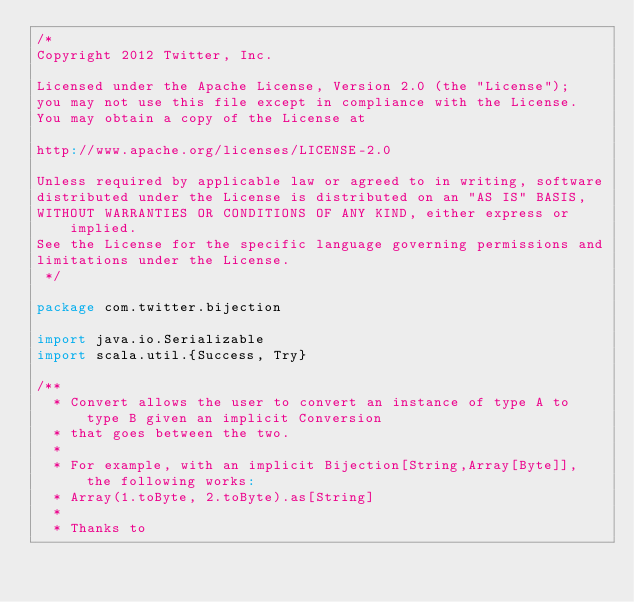<code> <loc_0><loc_0><loc_500><loc_500><_Scala_>/*
Copyright 2012 Twitter, Inc.

Licensed under the Apache License, Version 2.0 (the "License");
you may not use this file except in compliance with the License.
You may obtain a copy of the License at

http://www.apache.org/licenses/LICENSE-2.0

Unless required by applicable law or agreed to in writing, software
distributed under the License is distributed on an "AS IS" BASIS,
WITHOUT WARRANTIES OR CONDITIONS OF ANY KIND, either express or implied.
See the License for the specific language governing permissions and
limitations under the License.
 */

package com.twitter.bijection

import java.io.Serializable
import scala.util.{Success, Try}

/**
  * Convert allows the user to convert an instance of type A to type B given an implicit Conversion
  * that goes between the two.
  *
  * For example, with an implicit Bijection[String,Array[Byte]], the following works:
  * Array(1.toByte, 2.toByte).as[String]
  *
  * Thanks to</code> 